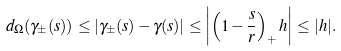<formula> <loc_0><loc_0><loc_500><loc_500>d _ { \Omega } ( \gamma _ { \pm } ( s ) ) \leq | \gamma _ { \pm } ( s ) - \gamma ( s ) | \leq \left | \left ( 1 - \frac { s } { r } \right ) _ { + } h \right | \leq | h | .</formula> 